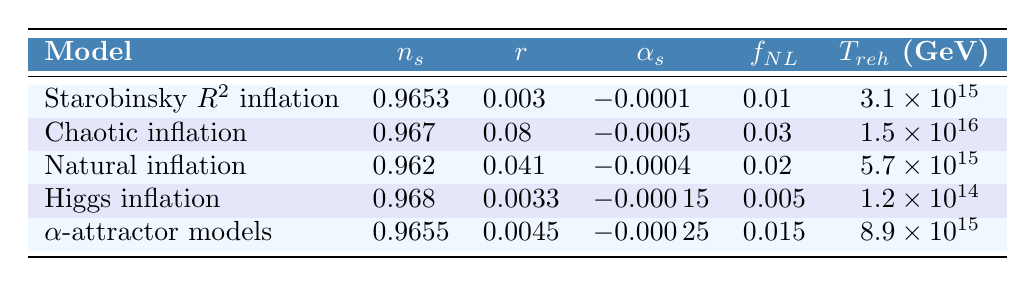What is the scalar spectral index (n_s) for Higgs inflation? The table lists the value of the scalar spectral index (n_s) for Higgs inflation in its respective row. According to the table, n_s for Higgs inflation is 0.968.
Answer: 0.968 Which inflation model has the highest tensor-to-scalar ratio (r)? By comparing the values of r across all models in the table, Chaotic inflation has the highest value at 0.08.
Answer: Chaotic inflation What is the average value of the non-Gaussianity parameter (f_NL) across all inflation models? The f_NL values are 0.01, 0.03, 0.02, 0.005, and 0.015. To find the average, sum these values: (0.01 + 0.03 + 0.02 + 0.005 + 0.015) = 0.08. Then divide by the number of models (5): 0.08/5 = 0.016.
Answer: 0.016 Is the running of the spectral index (α_s) for Natural inflation more negative than the one for Higgs inflation? The table shows α_s for Natural inflation as -0.0004 and for Higgs inflation as -0.00015. Comparing these values shows that -0.0004 is indeed more negative than -0.00015.
Answer: Yes What is the difference in reheating temperature (T_reh) between Chaotic inflation and Higgs inflation? The table gives the reheating temperature for Chaotic inflation as 1.5e16 GeV and for Higgs inflation as 1.2e14 GeV. To find the difference, we take 1.5e16 - 1.2e14 = 1.4872e16 GeV.
Answer: 1.4872e16 GeV Which inflation model has the lowest running of spectral index (α_s)? By examining the values in the table, the running of spectral index α_s is -0.0005 for Chaotic inflation, -0.0004 for Natural inflation, -0.00015 for Higgs inflation, -0.00025 for α-attractor models, and -0.0001 for Starobinsky R^2 inflation. The lowest value is -0.0005 for Chaotic inflation.
Answer: Chaotic inflation Are there any models with a reheating temperature (T_reh) below 1e15 GeV? The reheating temperatures (T_reh) are 3.1e15, 1.5e16, 5.7e15, 1.2e14, and 8.9e15 GeV. Since 1.2e14 is below 1e15, there is one model (Higgs inflation) that satisfies this condition.
Answer: Yes What is the sum of the scalar spectral index (n_s) values for Starobinsky R^2 inflation and α-attractor models? From the table, n_s for Starobinsky R^2 inflation is 0.9653, and for α-attractor models, it is 0.9655. The sum is 0.9653 + 0.9655 = 1.9308.
Answer: 1.9308 Which model has a tensor-to-scalar ratio (r) closest to 0.0045? By reviewing the table, the values of r are 0.003, 0.08, 0.041, 0.0033, and 0.0045. The model with r equal to 0.0045 is α-attractor models.
Answer: α-attractor models 